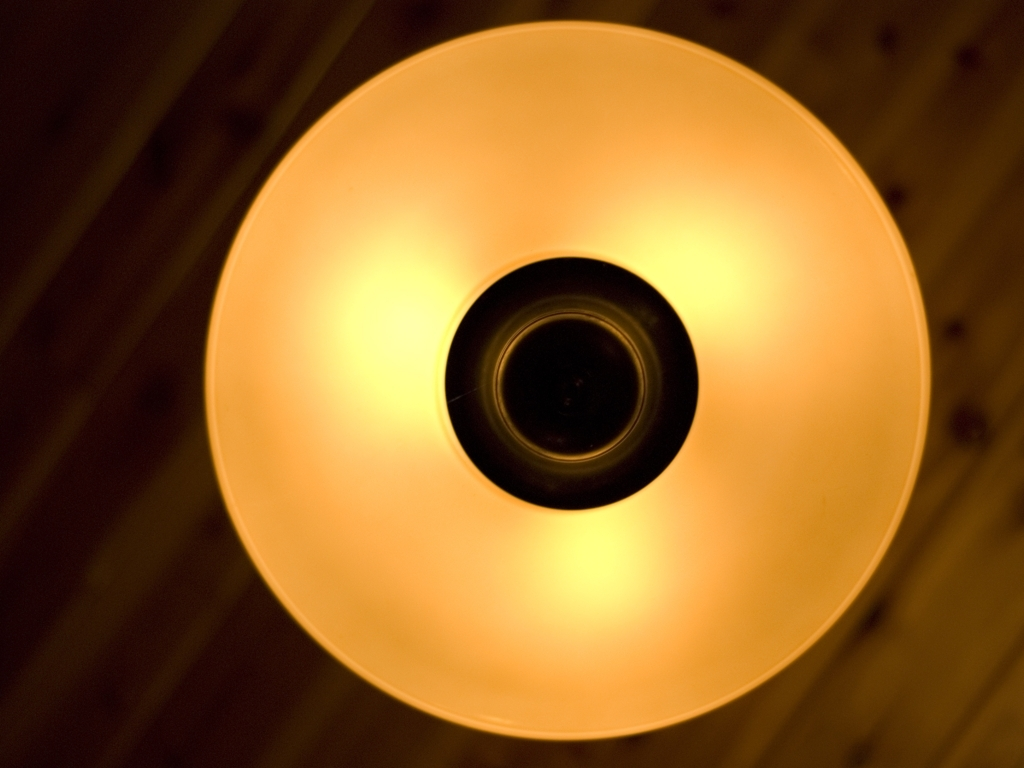How would you describe the overall image quality? The image is clear and well-lit with a focus on the warm glow of the light fixture, which provides a soft diffusion of light against the contrasting dark backdrop of the fixture's interior. However, the composition is quite common and lacks a dynamic subject, which may not appeal to all tastes or contexts. 